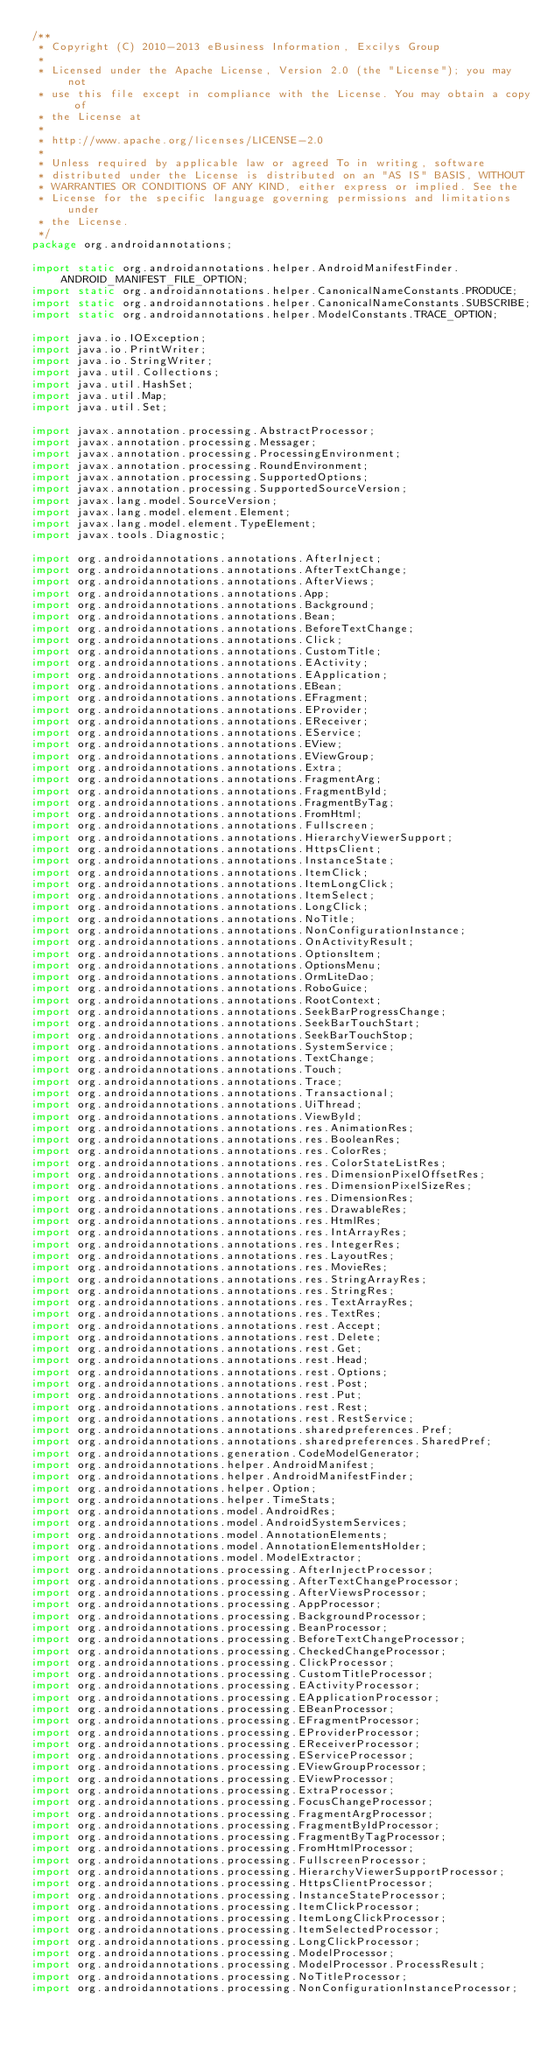Convert code to text. <code><loc_0><loc_0><loc_500><loc_500><_Java_>/**
 * Copyright (C) 2010-2013 eBusiness Information, Excilys Group
 *
 * Licensed under the Apache License, Version 2.0 (the "License"); you may not
 * use this file except in compliance with the License. You may obtain a copy of
 * the License at
 *
 * http://www.apache.org/licenses/LICENSE-2.0
 *
 * Unless required by applicable law or agreed To in writing, software
 * distributed under the License is distributed on an "AS IS" BASIS, WITHOUT
 * WARRANTIES OR CONDITIONS OF ANY KIND, either express or implied. See the
 * License for the specific language governing permissions and limitations under
 * the License.
 */
package org.androidannotations;

import static org.androidannotations.helper.AndroidManifestFinder.ANDROID_MANIFEST_FILE_OPTION;
import static org.androidannotations.helper.CanonicalNameConstants.PRODUCE;
import static org.androidannotations.helper.CanonicalNameConstants.SUBSCRIBE;
import static org.androidannotations.helper.ModelConstants.TRACE_OPTION;

import java.io.IOException;
import java.io.PrintWriter;
import java.io.StringWriter;
import java.util.Collections;
import java.util.HashSet;
import java.util.Map;
import java.util.Set;

import javax.annotation.processing.AbstractProcessor;
import javax.annotation.processing.Messager;
import javax.annotation.processing.ProcessingEnvironment;
import javax.annotation.processing.RoundEnvironment;
import javax.annotation.processing.SupportedOptions;
import javax.annotation.processing.SupportedSourceVersion;
import javax.lang.model.SourceVersion;
import javax.lang.model.element.Element;
import javax.lang.model.element.TypeElement;
import javax.tools.Diagnostic;

import org.androidannotations.annotations.AfterInject;
import org.androidannotations.annotations.AfterTextChange;
import org.androidannotations.annotations.AfterViews;
import org.androidannotations.annotations.App;
import org.androidannotations.annotations.Background;
import org.androidannotations.annotations.Bean;
import org.androidannotations.annotations.BeforeTextChange;
import org.androidannotations.annotations.Click;
import org.androidannotations.annotations.CustomTitle;
import org.androidannotations.annotations.EActivity;
import org.androidannotations.annotations.EApplication;
import org.androidannotations.annotations.EBean;
import org.androidannotations.annotations.EFragment;
import org.androidannotations.annotations.EProvider;
import org.androidannotations.annotations.EReceiver;
import org.androidannotations.annotations.EService;
import org.androidannotations.annotations.EView;
import org.androidannotations.annotations.EViewGroup;
import org.androidannotations.annotations.Extra;
import org.androidannotations.annotations.FragmentArg;
import org.androidannotations.annotations.FragmentById;
import org.androidannotations.annotations.FragmentByTag;
import org.androidannotations.annotations.FromHtml;
import org.androidannotations.annotations.Fullscreen;
import org.androidannotations.annotations.HierarchyViewerSupport;
import org.androidannotations.annotations.HttpsClient;
import org.androidannotations.annotations.InstanceState;
import org.androidannotations.annotations.ItemClick;
import org.androidannotations.annotations.ItemLongClick;
import org.androidannotations.annotations.ItemSelect;
import org.androidannotations.annotations.LongClick;
import org.androidannotations.annotations.NoTitle;
import org.androidannotations.annotations.NonConfigurationInstance;
import org.androidannotations.annotations.OnActivityResult;
import org.androidannotations.annotations.OptionsItem;
import org.androidannotations.annotations.OptionsMenu;
import org.androidannotations.annotations.OrmLiteDao;
import org.androidannotations.annotations.RoboGuice;
import org.androidannotations.annotations.RootContext;
import org.androidannotations.annotations.SeekBarProgressChange;
import org.androidannotations.annotations.SeekBarTouchStart;
import org.androidannotations.annotations.SeekBarTouchStop;
import org.androidannotations.annotations.SystemService;
import org.androidannotations.annotations.TextChange;
import org.androidannotations.annotations.Touch;
import org.androidannotations.annotations.Trace;
import org.androidannotations.annotations.Transactional;
import org.androidannotations.annotations.UiThread;
import org.androidannotations.annotations.ViewById;
import org.androidannotations.annotations.res.AnimationRes;
import org.androidannotations.annotations.res.BooleanRes;
import org.androidannotations.annotations.res.ColorRes;
import org.androidannotations.annotations.res.ColorStateListRes;
import org.androidannotations.annotations.res.DimensionPixelOffsetRes;
import org.androidannotations.annotations.res.DimensionPixelSizeRes;
import org.androidannotations.annotations.res.DimensionRes;
import org.androidannotations.annotations.res.DrawableRes;
import org.androidannotations.annotations.res.HtmlRes;
import org.androidannotations.annotations.res.IntArrayRes;
import org.androidannotations.annotations.res.IntegerRes;
import org.androidannotations.annotations.res.LayoutRes;
import org.androidannotations.annotations.res.MovieRes;
import org.androidannotations.annotations.res.StringArrayRes;
import org.androidannotations.annotations.res.StringRes;
import org.androidannotations.annotations.res.TextArrayRes;
import org.androidannotations.annotations.res.TextRes;
import org.androidannotations.annotations.rest.Accept;
import org.androidannotations.annotations.rest.Delete;
import org.androidannotations.annotations.rest.Get;
import org.androidannotations.annotations.rest.Head;
import org.androidannotations.annotations.rest.Options;
import org.androidannotations.annotations.rest.Post;
import org.androidannotations.annotations.rest.Put;
import org.androidannotations.annotations.rest.Rest;
import org.androidannotations.annotations.rest.RestService;
import org.androidannotations.annotations.sharedpreferences.Pref;
import org.androidannotations.annotations.sharedpreferences.SharedPref;
import org.androidannotations.generation.CodeModelGenerator;
import org.androidannotations.helper.AndroidManifest;
import org.androidannotations.helper.AndroidManifestFinder;
import org.androidannotations.helper.Option;
import org.androidannotations.helper.TimeStats;
import org.androidannotations.model.AndroidRes;
import org.androidannotations.model.AndroidSystemServices;
import org.androidannotations.model.AnnotationElements;
import org.androidannotations.model.AnnotationElementsHolder;
import org.androidannotations.model.ModelExtractor;
import org.androidannotations.processing.AfterInjectProcessor;
import org.androidannotations.processing.AfterTextChangeProcessor;
import org.androidannotations.processing.AfterViewsProcessor;
import org.androidannotations.processing.AppProcessor;
import org.androidannotations.processing.BackgroundProcessor;
import org.androidannotations.processing.BeanProcessor;
import org.androidannotations.processing.BeforeTextChangeProcessor;
import org.androidannotations.processing.CheckedChangeProcessor;
import org.androidannotations.processing.ClickProcessor;
import org.androidannotations.processing.CustomTitleProcessor;
import org.androidannotations.processing.EActivityProcessor;
import org.androidannotations.processing.EApplicationProcessor;
import org.androidannotations.processing.EBeanProcessor;
import org.androidannotations.processing.EFragmentProcessor;
import org.androidannotations.processing.EProviderProcessor;
import org.androidannotations.processing.EReceiverProcessor;
import org.androidannotations.processing.EServiceProcessor;
import org.androidannotations.processing.EViewGroupProcessor;
import org.androidannotations.processing.EViewProcessor;
import org.androidannotations.processing.ExtraProcessor;
import org.androidannotations.processing.FocusChangeProcessor;
import org.androidannotations.processing.FragmentArgProcessor;
import org.androidannotations.processing.FragmentByIdProcessor;
import org.androidannotations.processing.FragmentByTagProcessor;
import org.androidannotations.processing.FromHtmlProcessor;
import org.androidannotations.processing.FullscreenProcessor;
import org.androidannotations.processing.HierarchyViewerSupportProcessor;
import org.androidannotations.processing.HttpsClientProcessor;
import org.androidannotations.processing.InstanceStateProcessor;
import org.androidannotations.processing.ItemClickProcessor;
import org.androidannotations.processing.ItemLongClickProcessor;
import org.androidannotations.processing.ItemSelectedProcessor;
import org.androidannotations.processing.LongClickProcessor;
import org.androidannotations.processing.ModelProcessor;
import org.androidannotations.processing.ModelProcessor.ProcessResult;
import org.androidannotations.processing.NoTitleProcessor;
import org.androidannotations.processing.NonConfigurationInstanceProcessor;</code> 